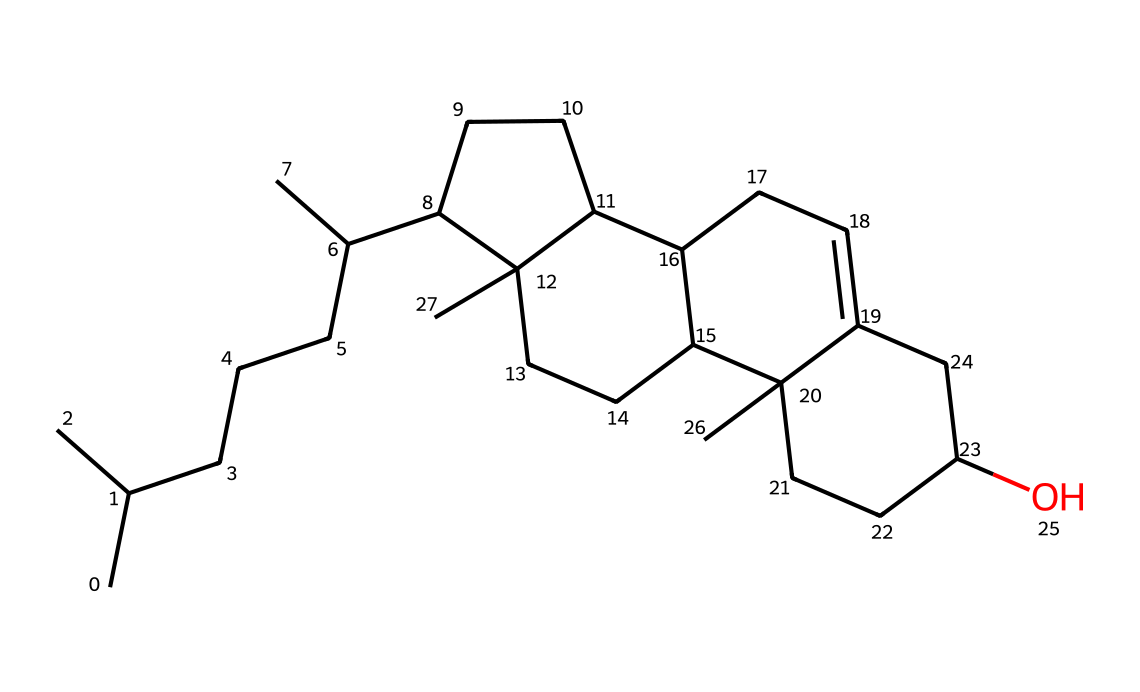What is the molecular formula of cholesterol? To determine the molecular formula, we analyze the structure. The SMILES notation indicates the presence of carbon (C), hydrogen (H), and oxygen (O). By counting the atoms represented, there are 27 carbons, 46 hydrogens, and 1 oxygen. Hence, the molecular formula is C27H46O.
Answer: C27H46O How many carbon atoms are present in cholesterol? The first step is to evaluate the SMILES representation for carbon symbols. By carefully counting each 'C', we find a total of 27 carbon atoms.
Answer: 27 What type of lipid is cholesterol classified as? Cholesterol is identified through its structure, which includes multiple hydrocarbon rings and a hydroxyl group (-OH) indicating it’s a sterol. This classification can be known from its role in the body and specific structure.
Answer: sterol How many rings are there in the cholesterol structure? Upon examining the structure, we notice several interconnected rings which form the core structure of cholesterol. There are four fused carbon rings visible in the structure.
Answer: 4 What role does cholesterol play in hormone production? Cholesterol serves as a precursor for the biosynthesis of steroid hormones, including sex hormones essential for regulating reproductive functions in female athletes, which is evident from its structural significance in hormone synthesis pathways.
Answer: precursor 